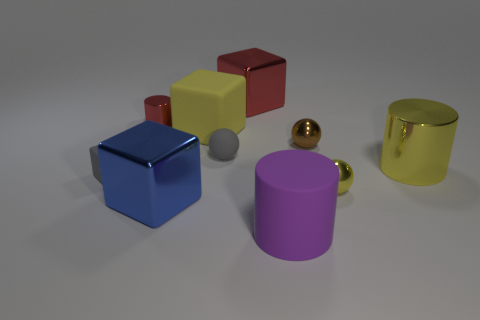Subtract all spheres. How many objects are left? 7 Add 2 brown rubber objects. How many brown rubber objects exist? 2 Subtract 1 yellow balls. How many objects are left? 9 Subtract all small cylinders. Subtract all large yellow shiny cylinders. How many objects are left? 8 Add 2 yellow metal objects. How many yellow metal objects are left? 4 